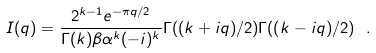Convert formula to latex. <formula><loc_0><loc_0><loc_500><loc_500>I ( q ) = \frac { 2 ^ { k - 1 } e ^ { - \pi { q } / 2 } } { \Gamma ( k ) \beta \alpha ^ { k } ( - i ) ^ { k } } \Gamma ( ( k + i q ) / 2 ) \Gamma ( ( k - i q ) / 2 ) \ .</formula> 